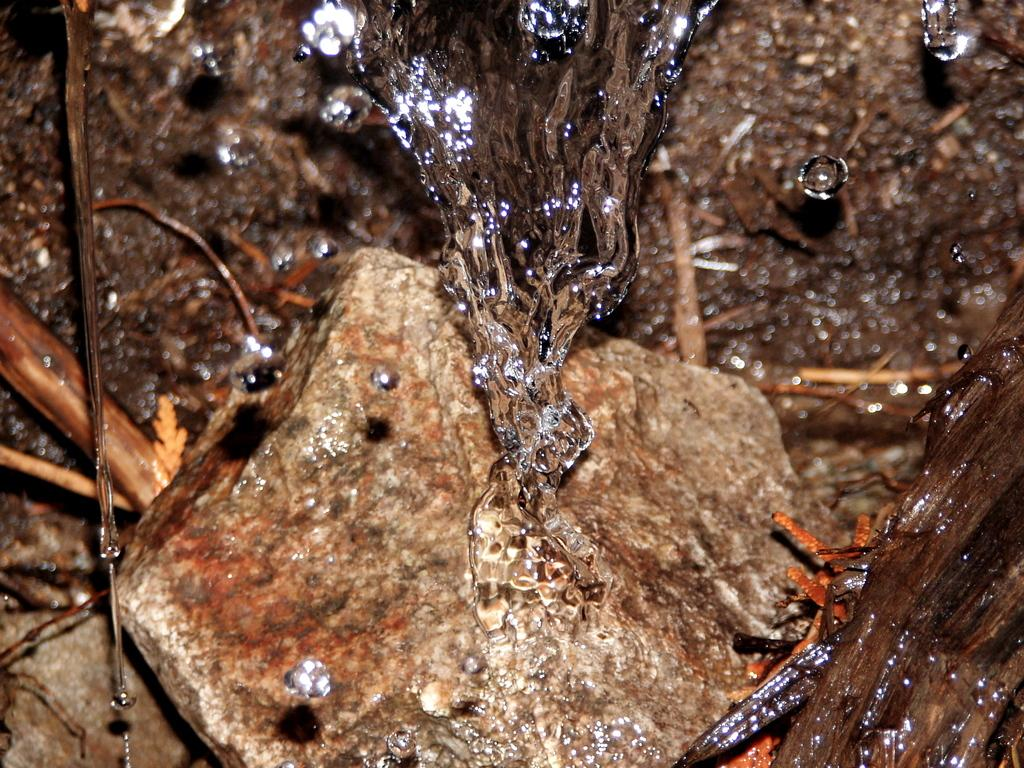What is the primary element visible in the image? There is water in the image. What other objects can be seen in the image? There are rocks and sticks on the ground in the image. What type of patch can be seen on the page in the image? There is no page or patch present in the image; it features water, rocks, and sticks. 